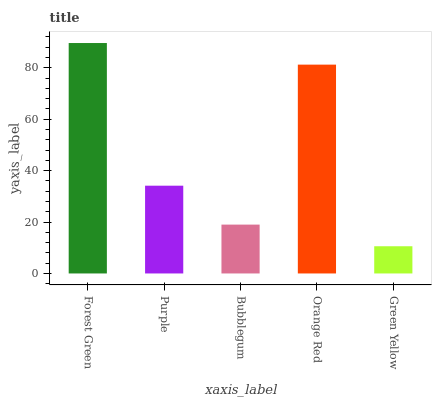Is Green Yellow the minimum?
Answer yes or no. Yes. Is Forest Green the maximum?
Answer yes or no. Yes. Is Purple the minimum?
Answer yes or no. No. Is Purple the maximum?
Answer yes or no. No. Is Forest Green greater than Purple?
Answer yes or no. Yes. Is Purple less than Forest Green?
Answer yes or no. Yes. Is Purple greater than Forest Green?
Answer yes or no. No. Is Forest Green less than Purple?
Answer yes or no. No. Is Purple the high median?
Answer yes or no. Yes. Is Purple the low median?
Answer yes or no. Yes. Is Green Yellow the high median?
Answer yes or no. No. Is Bubblegum the low median?
Answer yes or no. No. 